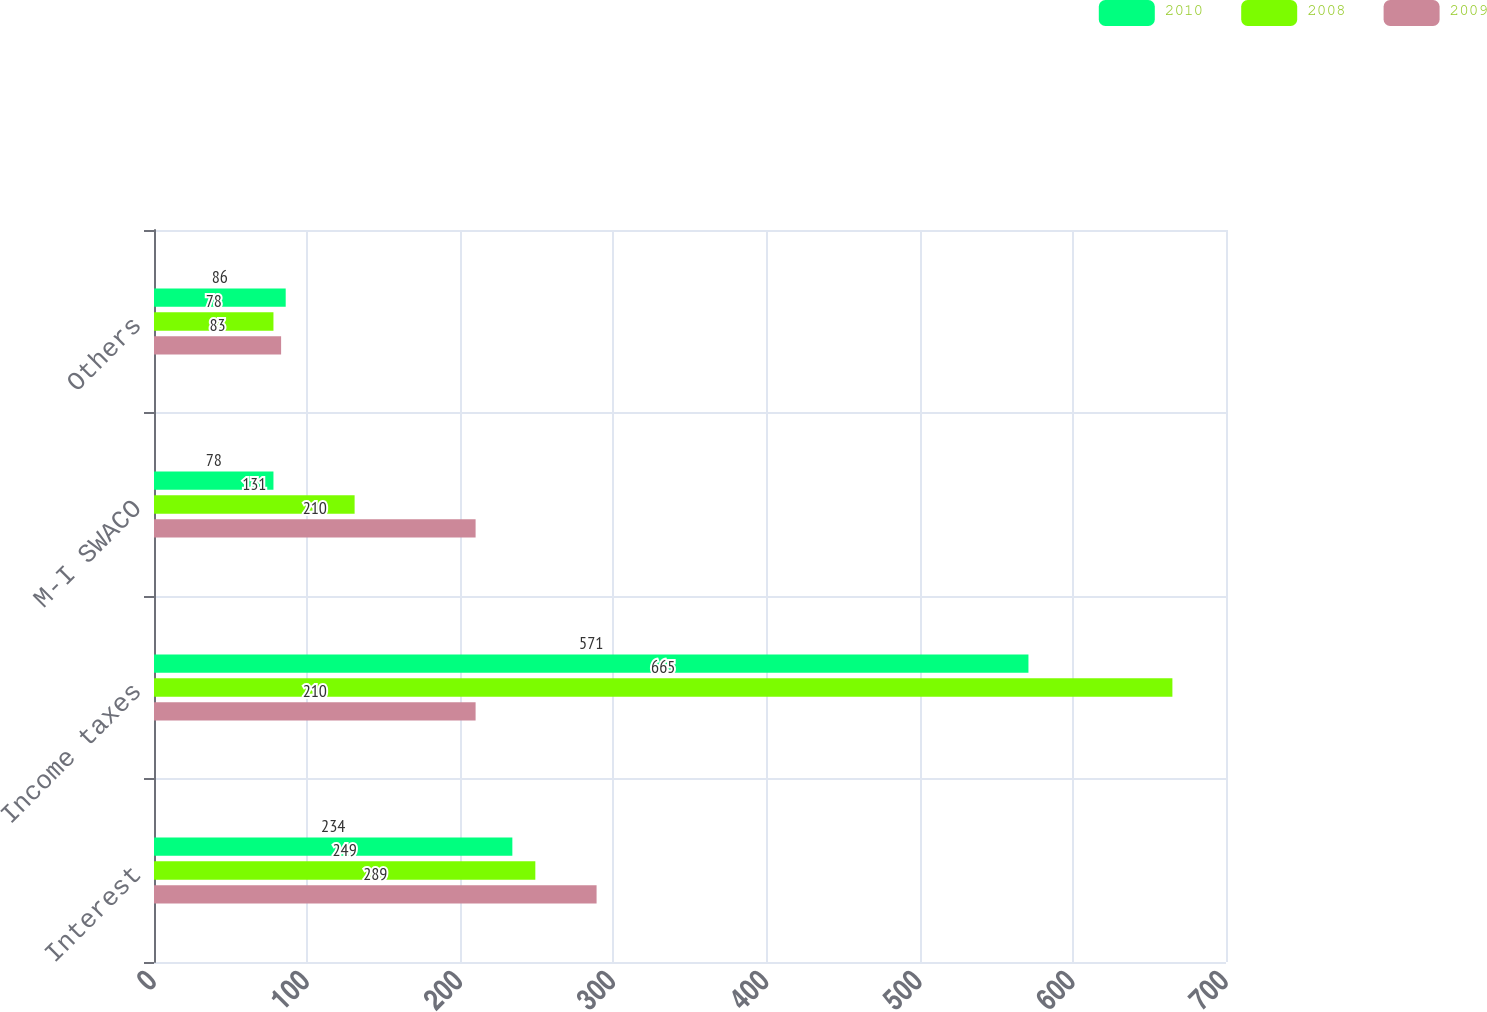<chart> <loc_0><loc_0><loc_500><loc_500><stacked_bar_chart><ecel><fcel>Interest<fcel>Income taxes<fcel>M-I SWACO<fcel>Others<nl><fcel>2010<fcel>234<fcel>571<fcel>78<fcel>86<nl><fcel>2008<fcel>249<fcel>665<fcel>131<fcel>78<nl><fcel>2009<fcel>289<fcel>210<fcel>210<fcel>83<nl></chart> 